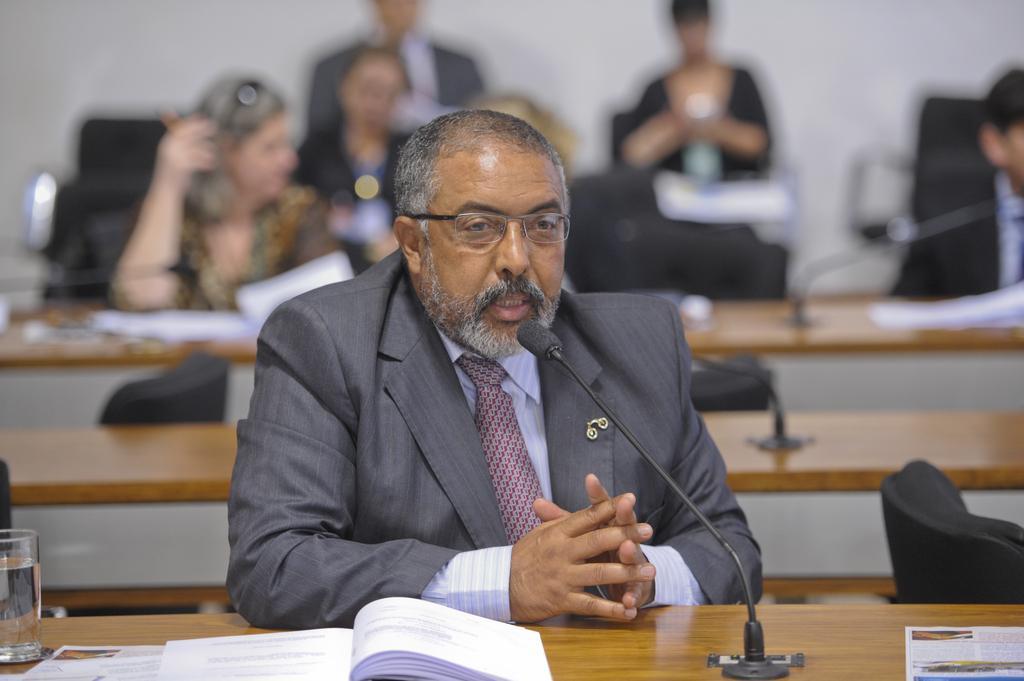Can you describe this image briefly? In the picture we can see a man sitting near to the desk and he is in blazer, tie and shirt and on the desk, we can see a book which is opened and a glass with water and a microphone and behind him we can see some people are also sitting near the desks and two people are standing near the wall. 